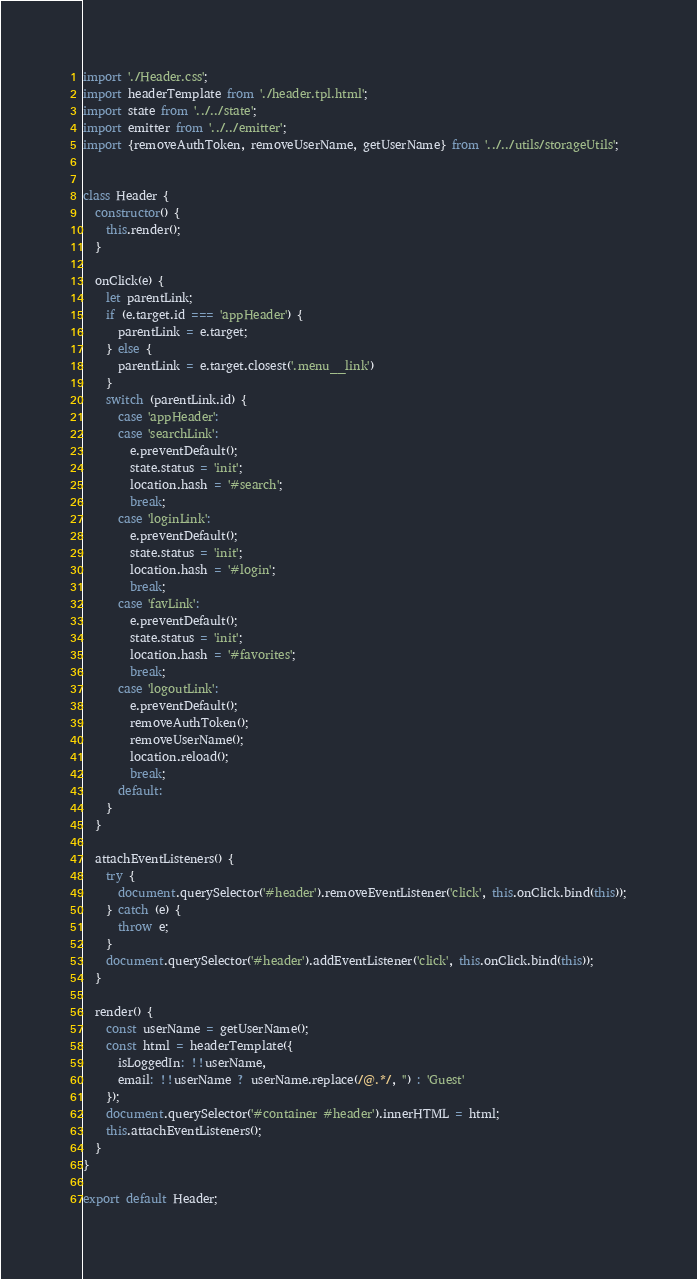Convert code to text. <code><loc_0><loc_0><loc_500><loc_500><_JavaScript_>import './Header.css';
import headerTemplate from './header.tpl.html';
import state from '../../state';
import emitter from '../../emitter';
import {removeAuthToken, removeUserName, getUserName} from '../../utils/storageUtils';


class Header {
  constructor() {
    this.render();
  }

  onClick(e) {
    let parentLink;
    if (e.target.id === 'appHeader') {
      parentLink = e.target;
    } else {
      parentLink = e.target.closest('.menu__link')
    }
    switch (parentLink.id) {
      case 'appHeader':
      case 'searchLink':
        e.preventDefault();
        state.status = 'init';
        location.hash = '#search';
        break;
      case 'loginLink':
        e.preventDefault();
        state.status = 'init';
        location.hash = '#login';
        break;
      case 'favLink':
        e.preventDefault();
        state.status = 'init';
        location.hash = '#favorites';
        break;
      case 'logoutLink':
        e.preventDefault();
        removeAuthToken();
        removeUserName();
        location.reload();
        break;
      default:
    }
  }

  attachEventListeners() {
    try {
      document.querySelector('#header').removeEventListener('click', this.onClick.bind(this));
    } catch (e) {
      throw e;
    }
    document.querySelector('#header').addEventListener('click', this.onClick.bind(this));
  }

  render() {
    const userName = getUserName();
    const html = headerTemplate({
      isLoggedIn: !!userName,
      email: !!userName ? userName.replace(/@.*/, '') : 'Guest'
    });
    document.querySelector('#container #header').innerHTML = html;
    this.attachEventListeners();
  }
}

export default Header;
</code> 